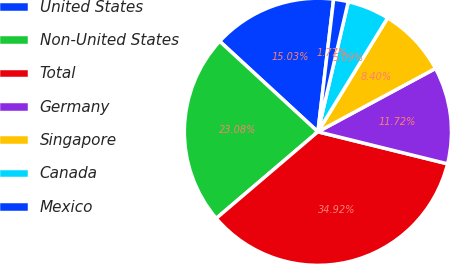Convert chart to OTSL. <chart><loc_0><loc_0><loc_500><loc_500><pie_chart><fcel>United States<fcel>Non-United States<fcel>Total<fcel>Germany<fcel>Singapore<fcel>Canada<fcel>Mexico<nl><fcel>15.03%<fcel>23.08%<fcel>34.92%<fcel>11.72%<fcel>8.4%<fcel>5.09%<fcel>1.77%<nl></chart> 